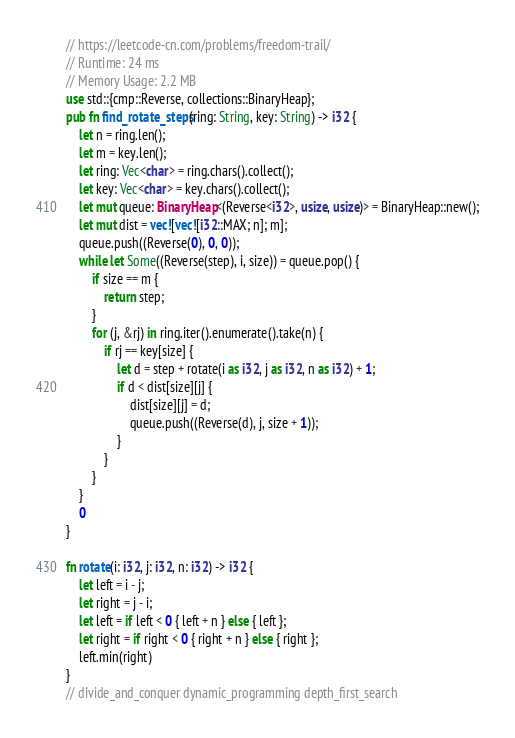<code> <loc_0><loc_0><loc_500><loc_500><_Rust_>// https://leetcode-cn.com/problems/freedom-trail/
// Runtime: 24 ms
// Memory Usage: 2.2 MB
use std::{cmp::Reverse, collections::BinaryHeap};
pub fn find_rotate_steps(ring: String, key: String) -> i32 {
    let n = ring.len();
    let m = key.len();
    let ring: Vec<char> = ring.chars().collect();
    let key: Vec<char> = key.chars().collect();
    let mut queue: BinaryHeap<(Reverse<i32>, usize, usize)> = BinaryHeap::new();
    let mut dist = vec![vec![i32::MAX; n]; m];
    queue.push((Reverse(0), 0, 0));
    while let Some((Reverse(step), i, size)) = queue.pop() {
        if size == m {
            return step;
        }
        for (j, &rj) in ring.iter().enumerate().take(n) {
            if rj == key[size] {
                let d = step + rotate(i as i32, j as i32, n as i32) + 1;
                if d < dist[size][j] {
                    dist[size][j] = d;
                    queue.push((Reverse(d), j, size + 1));
                }
            }
        }
    }
    0
}

fn rotate(i: i32, j: i32, n: i32) -> i32 {
    let left = i - j;
    let right = j - i;
    let left = if left < 0 { left + n } else { left };
    let right = if right < 0 { right + n } else { right };
    left.min(right)
}
// divide_and_conquer dynamic_programming depth_first_search</code> 